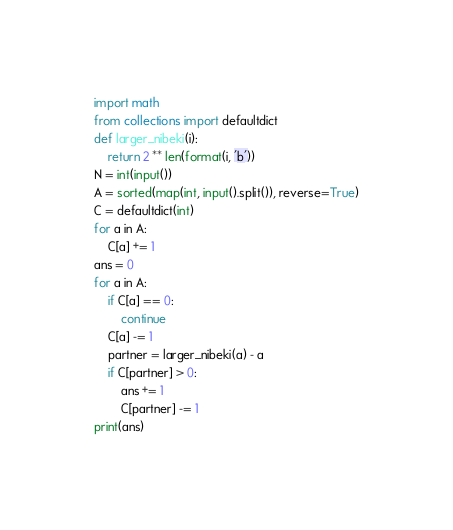<code> <loc_0><loc_0><loc_500><loc_500><_Python_>import math
from collections import defaultdict
def larger_nibeki(i):
    return 2 ** len(format(i, 'b'))
N = int(input())
A = sorted(map(int, input().split()), reverse=True)
C = defaultdict(int)
for a in A:
    C[a] += 1
ans = 0
for a in A:
    if C[a] == 0:
        continue
    C[a] -= 1
    partner = larger_nibeki(a) - a
    if C[partner] > 0:
        ans += 1
        C[partner] -= 1
print(ans)</code> 